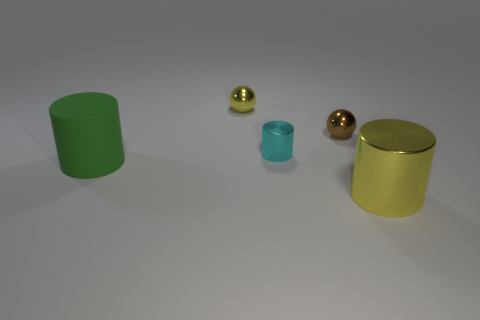There is a metallic ball that is in front of the yellow ball; does it have the same size as the tiny yellow ball?
Keep it short and to the point. Yes. What number of balls are tiny brown objects or yellow shiny things?
Your answer should be very brief. 2. What is the large object that is left of the yellow ball made of?
Provide a short and direct response. Rubber. Is the number of tiny gray balls less than the number of big green things?
Provide a short and direct response. Yes. There is a metal object that is both in front of the small brown thing and behind the green cylinder; what size is it?
Your answer should be compact. Small. What is the size of the cylinder on the left side of the metallic object left of the small metallic cylinder that is on the left side of the brown object?
Provide a succinct answer. Large. How many other objects are there of the same color as the tiny cylinder?
Offer a terse response. 0. Does the small sphere that is left of the small cyan cylinder have the same color as the big metallic thing?
Provide a short and direct response. Yes. How many things are either big yellow shiny cylinders or tiny balls?
Your answer should be compact. 3. The shiny cylinder left of the big yellow cylinder is what color?
Ensure brevity in your answer.  Cyan. 